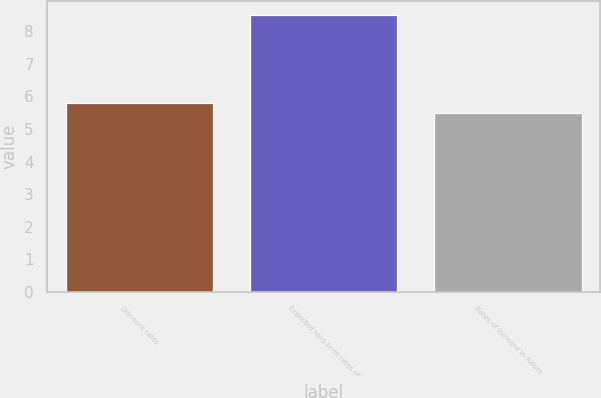Convert chart to OTSL. <chart><loc_0><loc_0><loc_500><loc_500><bar_chart><fcel>Discount rates<fcel>Expected long-term rates of<fcel>Rates of increase in future<nl><fcel>5.8<fcel>8.5<fcel>5.5<nl></chart> 